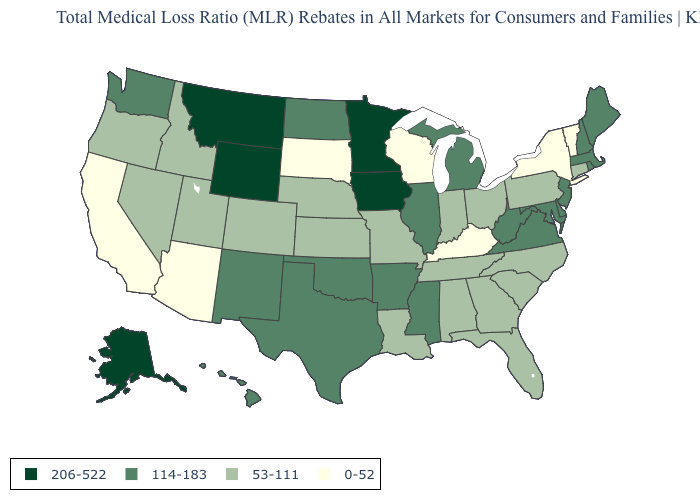What is the lowest value in the USA?
Keep it brief. 0-52. Name the states that have a value in the range 53-111?
Short answer required. Alabama, Colorado, Connecticut, Florida, Georgia, Idaho, Indiana, Kansas, Louisiana, Missouri, Nebraska, Nevada, North Carolina, Ohio, Oregon, Pennsylvania, South Carolina, Tennessee, Utah. Which states hav the highest value in the West?
Give a very brief answer. Alaska, Montana, Wyoming. Is the legend a continuous bar?
Write a very short answer. No. What is the highest value in the South ?
Short answer required. 114-183. What is the value of Washington?
Concise answer only. 114-183. What is the value of Rhode Island?
Answer briefly. 114-183. What is the value of Rhode Island?
Give a very brief answer. 114-183. Does Tennessee have a higher value than Arizona?
Write a very short answer. Yes. What is the lowest value in the Northeast?
Be succinct. 0-52. What is the value of South Dakota?
Be succinct. 0-52. What is the lowest value in the West?
Be succinct. 0-52. Which states have the highest value in the USA?
Quick response, please. Alaska, Iowa, Minnesota, Montana, Wyoming. Does Hawaii have the highest value in the West?
Short answer required. No. Name the states that have a value in the range 53-111?
Keep it brief. Alabama, Colorado, Connecticut, Florida, Georgia, Idaho, Indiana, Kansas, Louisiana, Missouri, Nebraska, Nevada, North Carolina, Ohio, Oregon, Pennsylvania, South Carolina, Tennessee, Utah. 